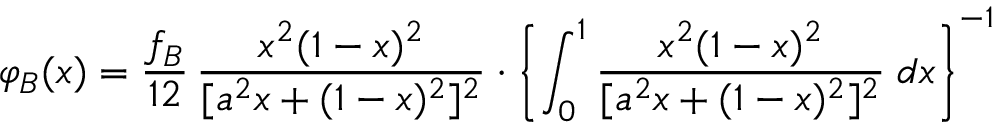Convert formula to latex. <formula><loc_0><loc_0><loc_500><loc_500>\varphi _ { B } ( x ) = \frac { f _ { B } } { 1 2 } \, \frac { x ^ { 2 } ( 1 - x ) ^ { 2 } } { [ a ^ { 2 } x + ( 1 - x ) ^ { 2 } ] ^ { 2 } } \cdot \left \{ \int _ { 0 } ^ { 1 } \frac { x ^ { 2 } ( 1 - x ) ^ { 2 } } { [ a ^ { 2 } x + ( 1 - x ) ^ { 2 } ] ^ { 2 } } \, d x \right \} ^ { - 1 }</formula> 